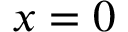Convert formula to latex. <formula><loc_0><loc_0><loc_500><loc_500>x = 0</formula> 